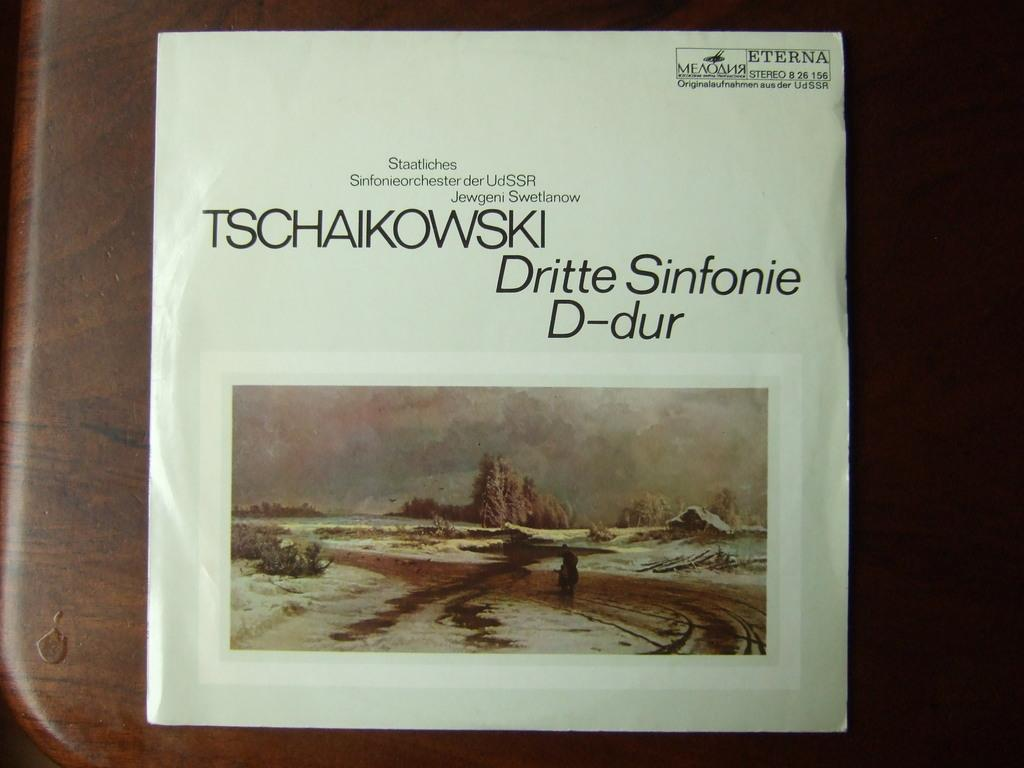<image>
Offer a succinct explanation of the picture presented. An album from composer Tschaikowski sits on what looks to be a desk. 